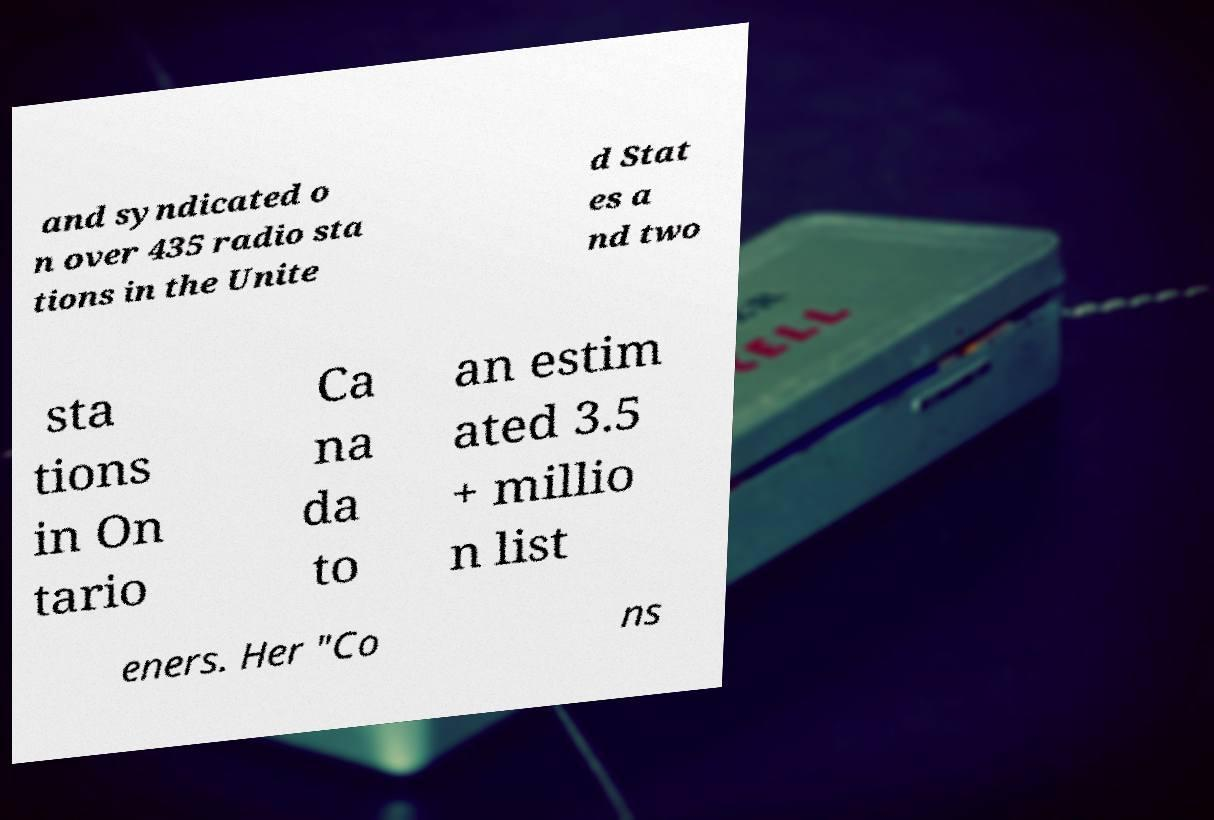Please read and relay the text visible in this image. What does it say? and syndicated o n over 435 radio sta tions in the Unite d Stat es a nd two sta tions in On tario Ca na da to an estim ated 3.5 + millio n list eners. Her "Co ns 